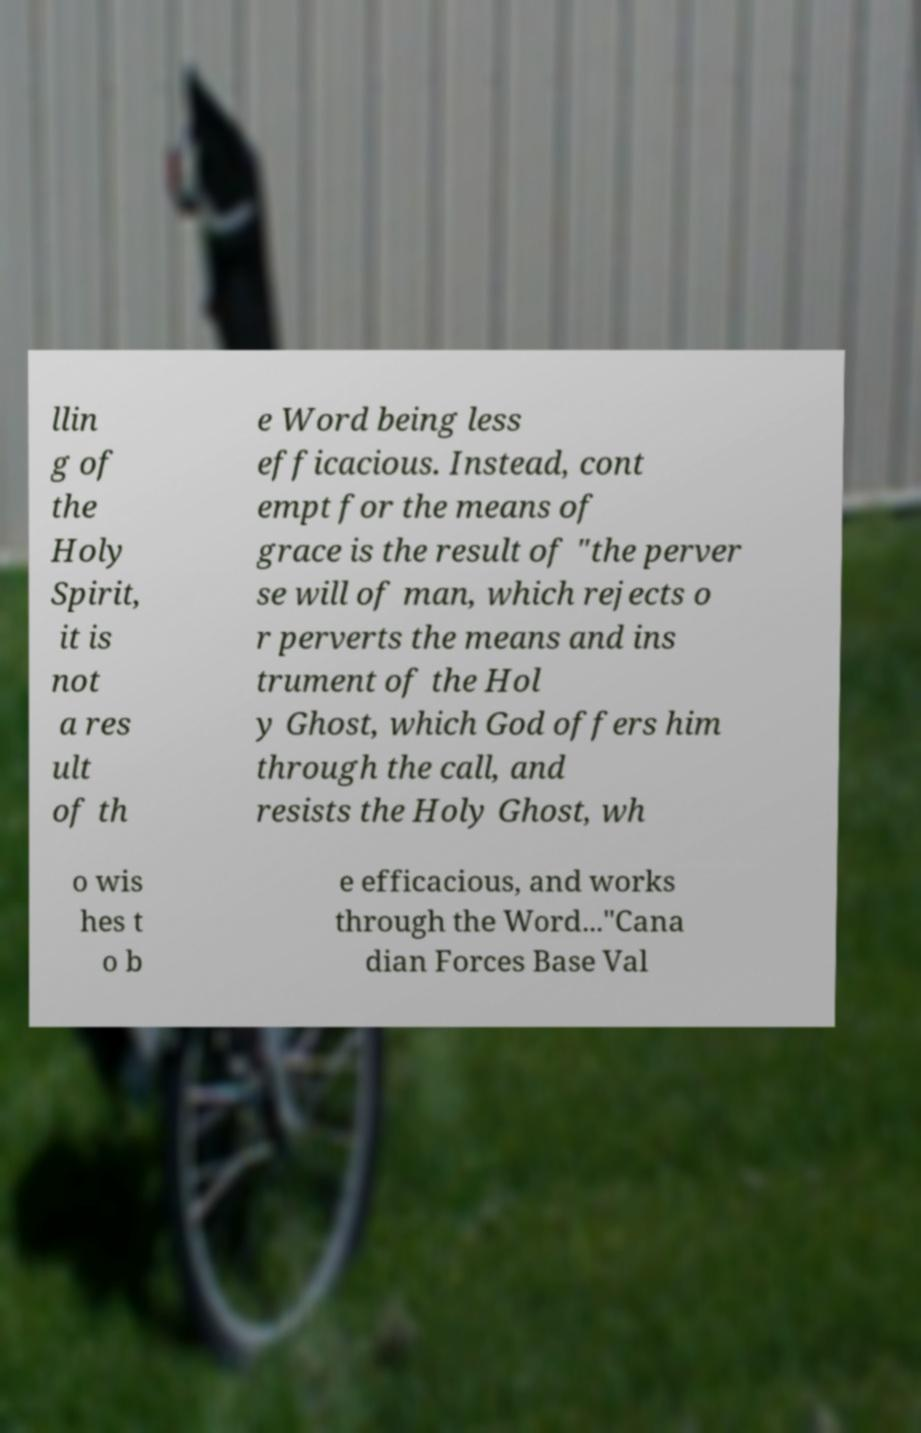For documentation purposes, I need the text within this image transcribed. Could you provide that? llin g of the Holy Spirit, it is not a res ult of th e Word being less efficacious. Instead, cont empt for the means of grace is the result of "the perver se will of man, which rejects o r perverts the means and ins trument of the Hol y Ghost, which God offers him through the call, and resists the Holy Ghost, wh o wis hes t o b e efficacious, and works through the Word..."Cana dian Forces Base Val 